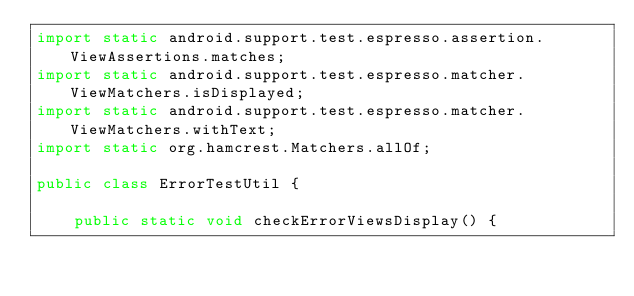<code> <loc_0><loc_0><loc_500><loc_500><_Java_>import static android.support.test.espresso.assertion.ViewAssertions.matches;
import static android.support.test.espresso.matcher.ViewMatchers.isDisplayed;
import static android.support.test.espresso.matcher.ViewMatchers.withText;
import static org.hamcrest.Matchers.allOf;

public class ErrorTestUtil {

    public static void checkErrorViewsDisplay() {</code> 